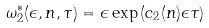<formula> <loc_0><loc_0><loc_500><loc_500>\omega _ { 2 } ^ { * } ( \epsilon , n , \tau ) = \epsilon \exp \left ( c _ { 2 } ( n ) \epsilon \tau \right )</formula> 